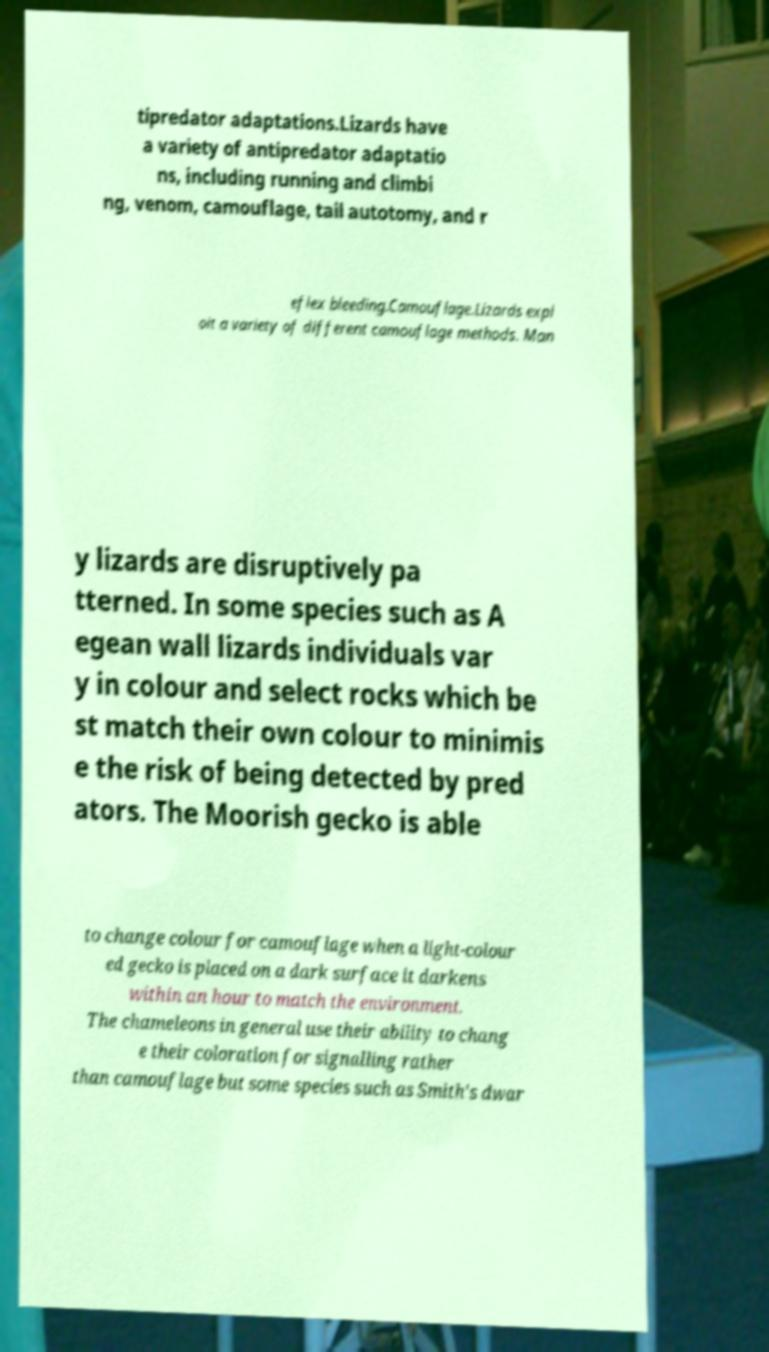Can you accurately transcribe the text from the provided image for me? tipredator adaptations.Lizards have a variety of antipredator adaptatio ns, including running and climbi ng, venom, camouflage, tail autotomy, and r eflex bleeding.Camouflage.Lizards expl oit a variety of different camouflage methods. Man y lizards are disruptively pa tterned. In some species such as A egean wall lizards individuals var y in colour and select rocks which be st match their own colour to minimis e the risk of being detected by pred ators. The Moorish gecko is able to change colour for camouflage when a light-colour ed gecko is placed on a dark surface it darkens within an hour to match the environment. The chameleons in general use their ability to chang e their coloration for signalling rather than camouflage but some species such as Smith's dwar 